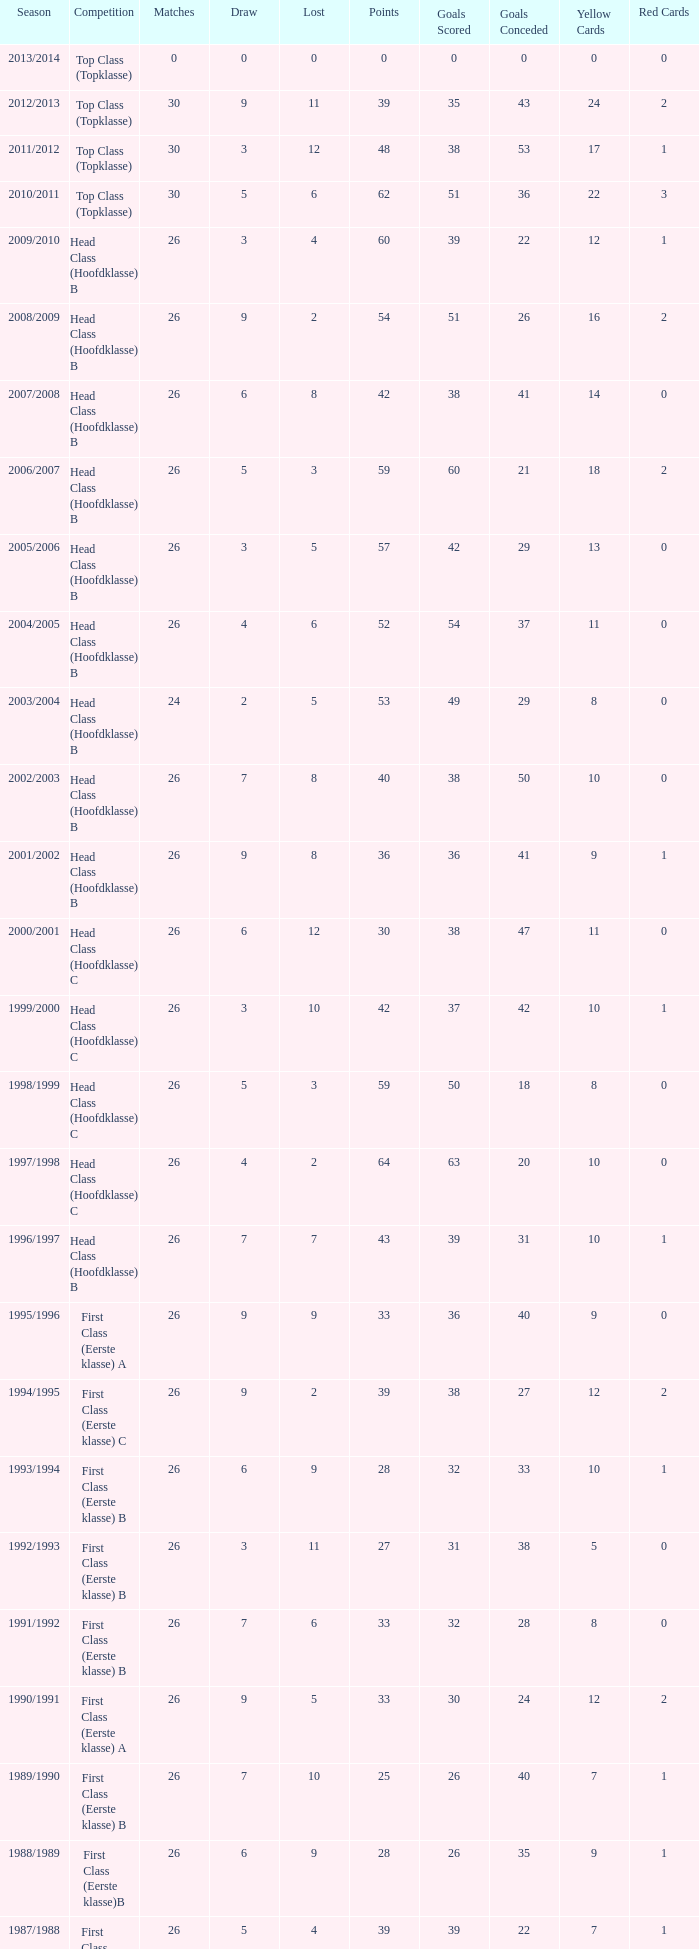In which competitive event does the score go beyond 30, a draw stays under 5, and a loss exceeds 10? Top Class (Topklasse). 